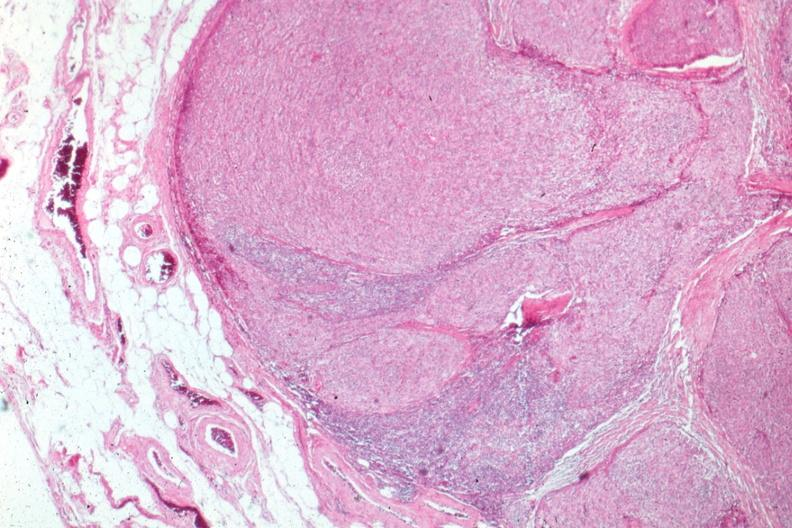s hematologic present?
Answer the question using a single word or phrase. Yes 